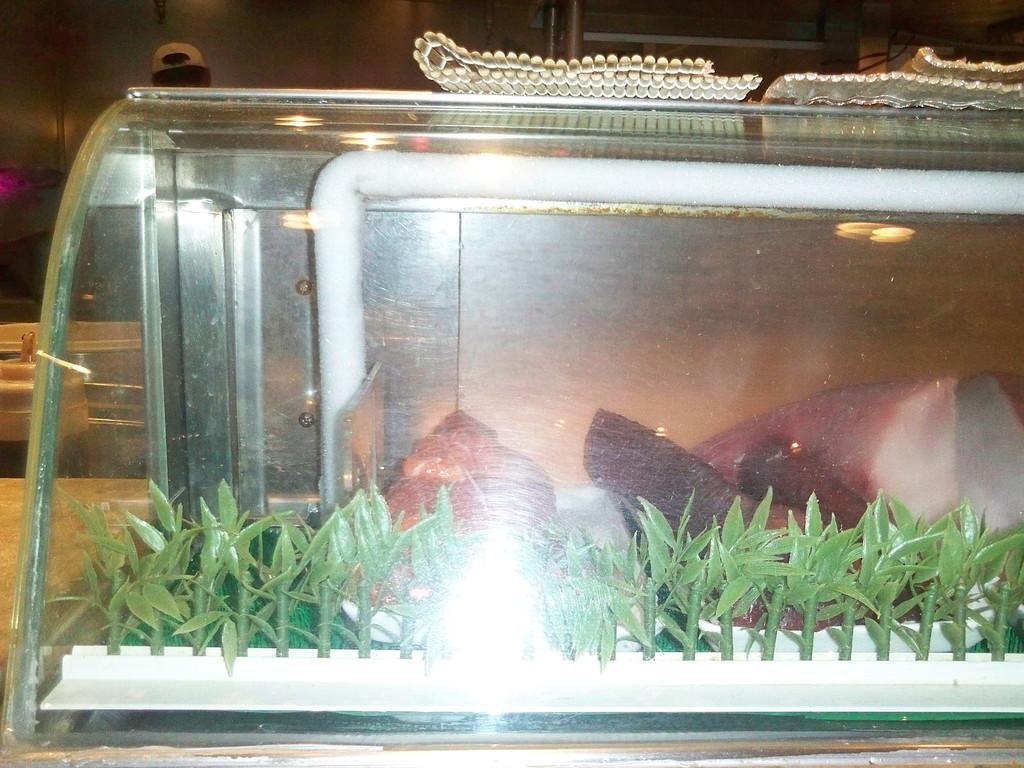Can you describe this image briefly? In this image we can see food items and depictions of plants placed in a glass object. In the background of the image we can see a person wearing a cap. 